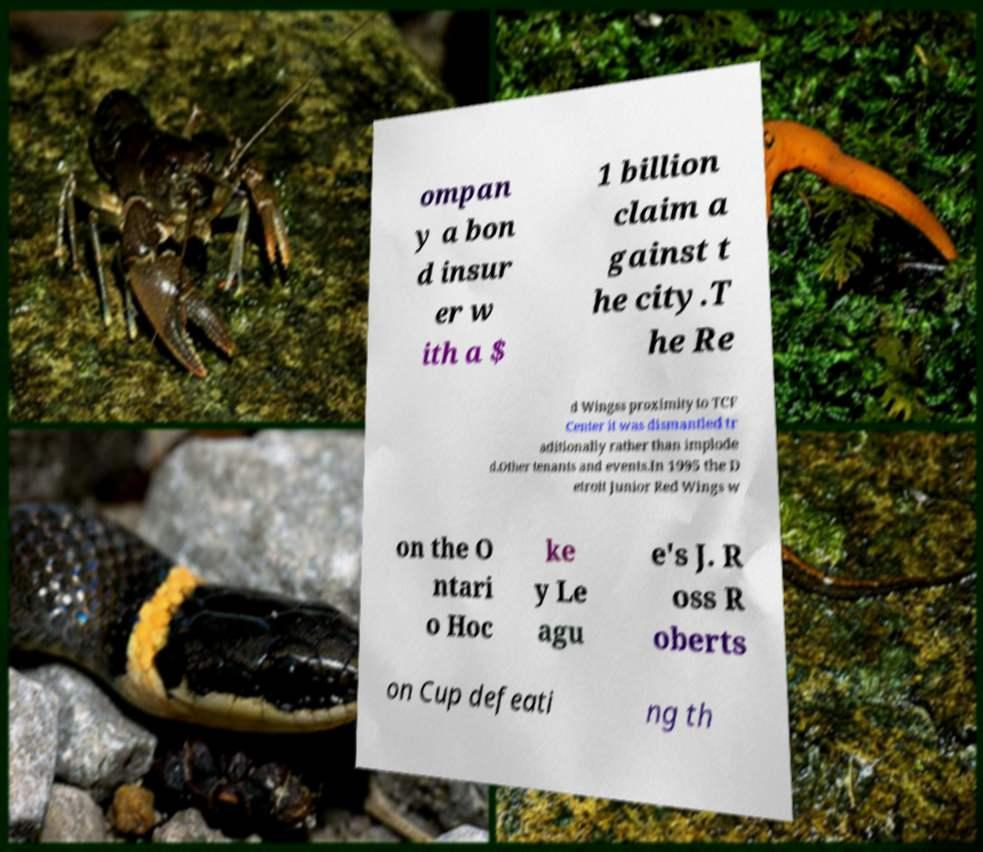Can you read and provide the text displayed in the image?This photo seems to have some interesting text. Can you extract and type it out for me? ompan y a bon d insur er w ith a $ 1 billion claim a gainst t he city.T he Re d Wingss proximity to TCF Center it was dismantled tr aditionally rather than implode d.Other tenants and events.In 1995 the D etroit Junior Red Wings w on the O ntari o Hoc ke y Le agu e's J. R oss R oberts on Cup defeati ng th 